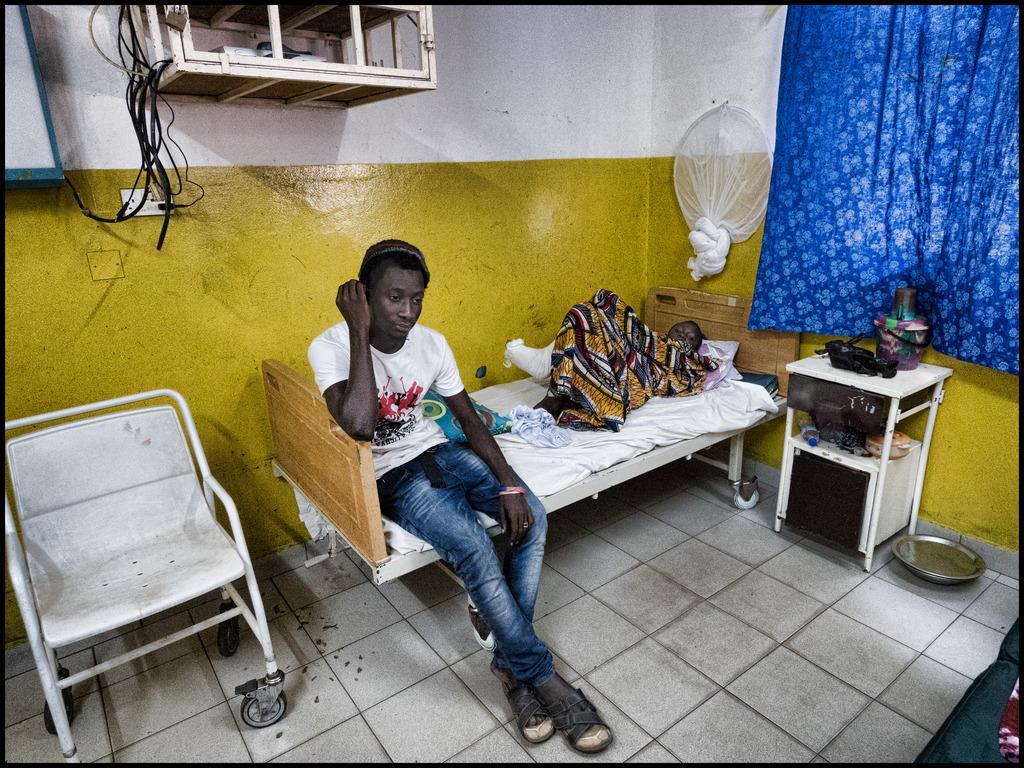Please provide a concise description of this image. In this image I can see the person sitting on the bed and wearing the white and blue color dress. I can see another person lying on the bed with the blanket. To the left there is a chair. To the right I can see the table with some objects and the blue color curtain. In the background I can see the some wooden boxes to the wall. The wall is in yellow and white color. 